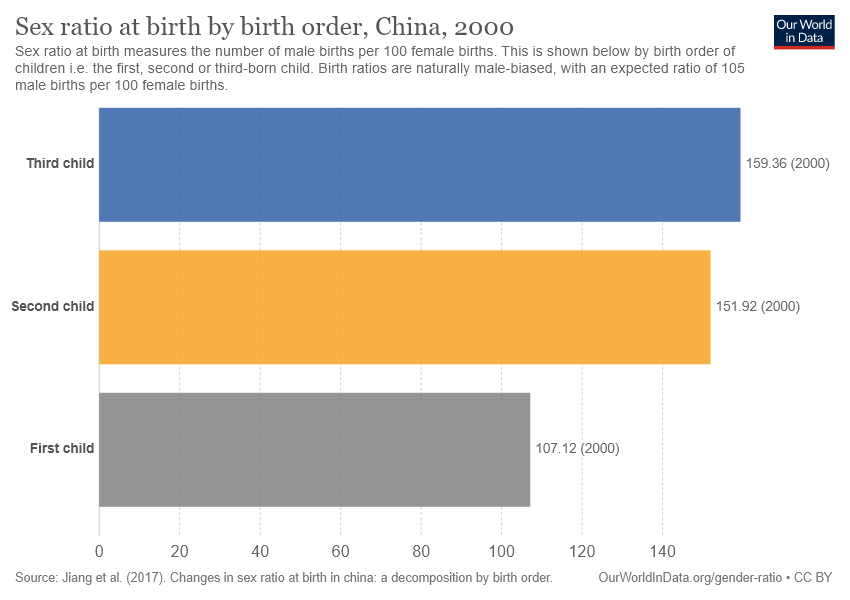Highlight a few significant elements in this photo. The value of the largest bar is 52.24, while the value of the smallest bar is 52.24. There are 3 bars in the graph. 